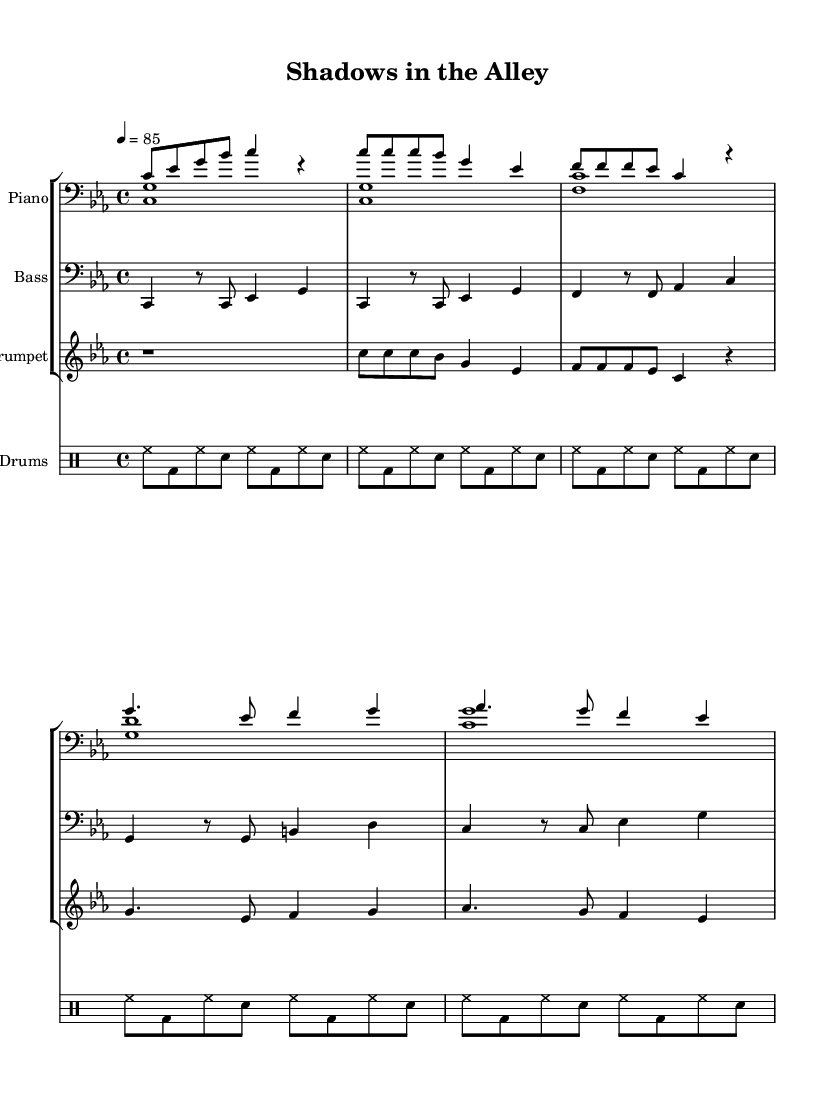What is the key signature of this music? The key signature is C minor, which has three flats. This can be identified by the key signature at the beginning of the score where the flats are marked.
Answer: C minor What is the time signature of this music? The time signature is 4/4, indicating four beats per measure, as shown at the beginning of the score.
Answer: 4/4 What is the tempo marking of the piece? The tempo marking indicates a speed of quarter note equals 85 beats per minute, which is specified in the tempo instruction within the score.
Answer: 85 Which instrument has a clef change? The trumpet has a treble clef, while the bass instrument features a bass clef. The clef is visible at the beginning of each staff, indicating the type of notes that will be used.
Answer: Trumpet How many measures are in the piano's right hand part? The piano's right hand part consists of 8 measures, which can be counted by looking at the bar lines within the staff. Each segment divided by bar lines represents a measure.
Answer: 8 What rhythmic pattern is predominantly used in the drum section? The dominant rhythmic pattern in the drum section consists of hi-hat hits interleaved with bass drum and snare hits. This is observable from the repeated drum pattern notated in the drum staff.
Answer: Hi-hat 